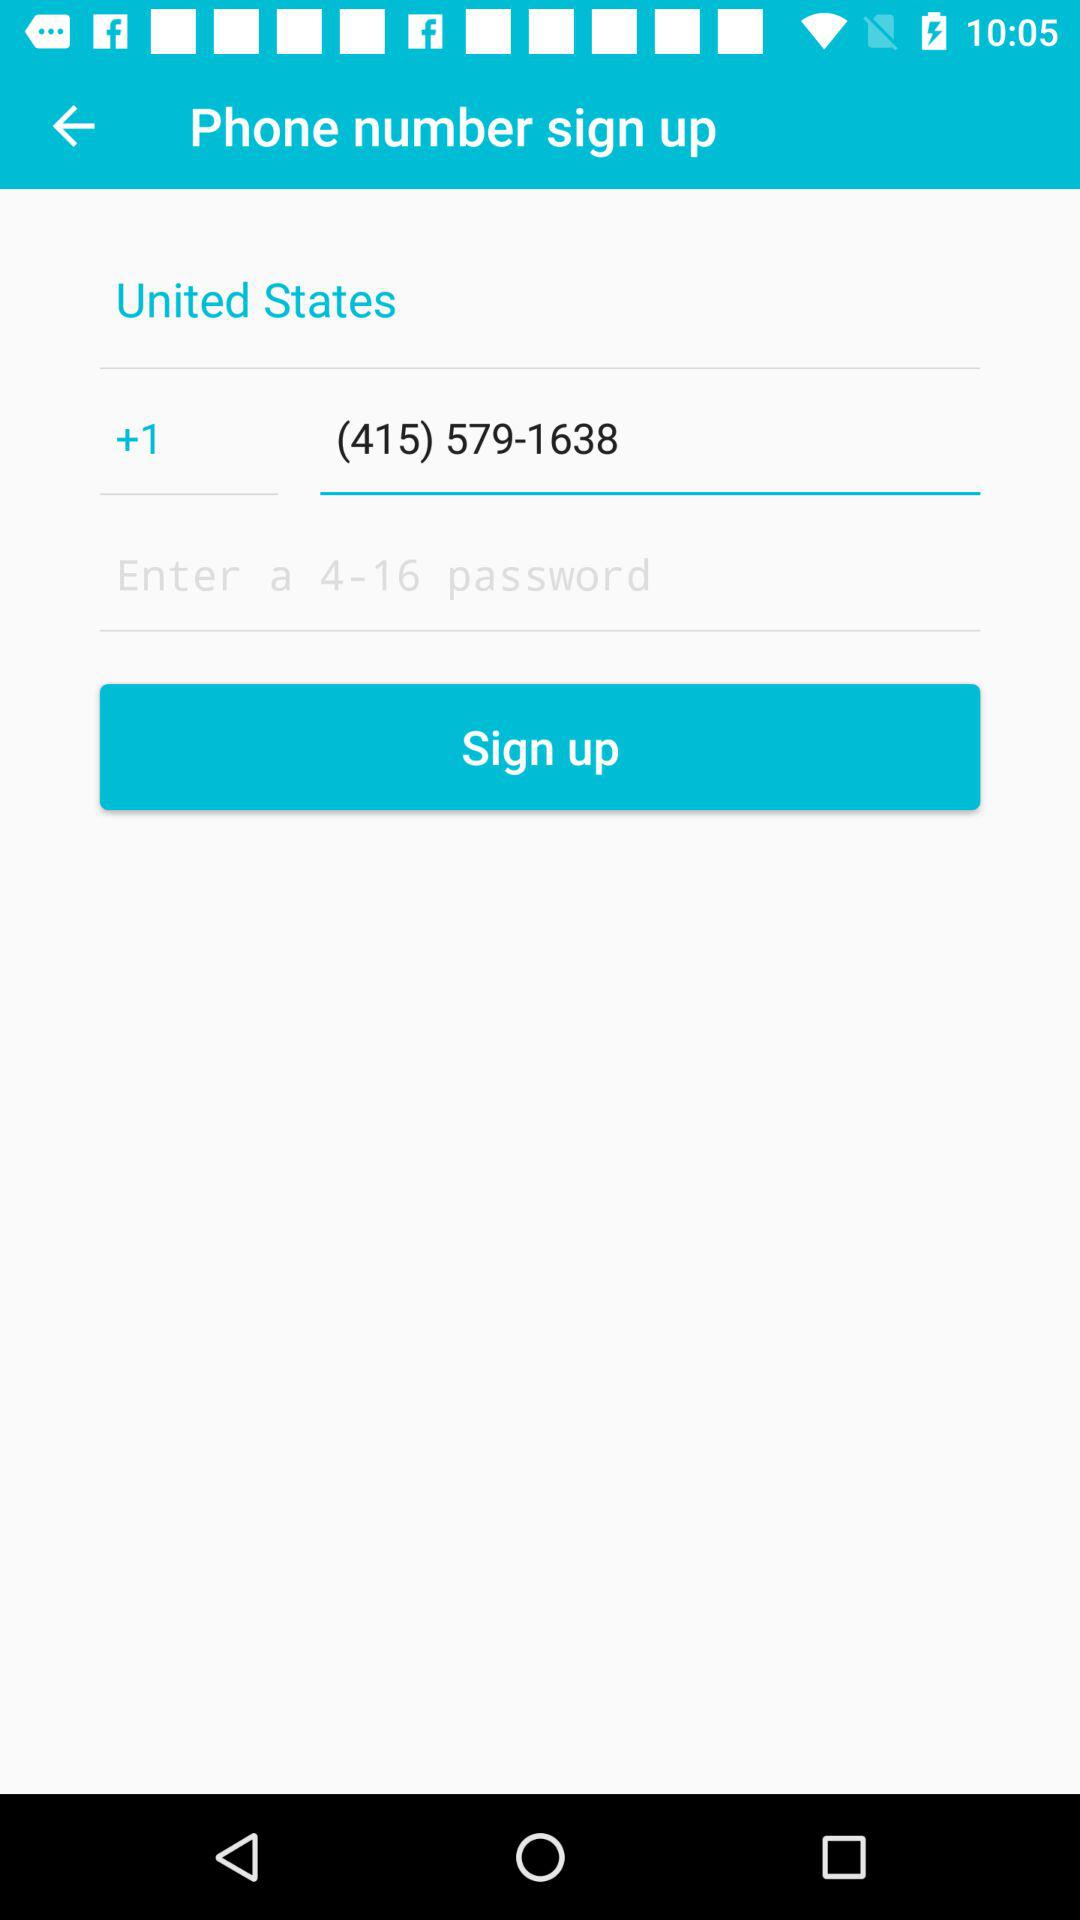Who is signing up?
When the provided information is insufficient, respond with <no answer>. <no answer> 